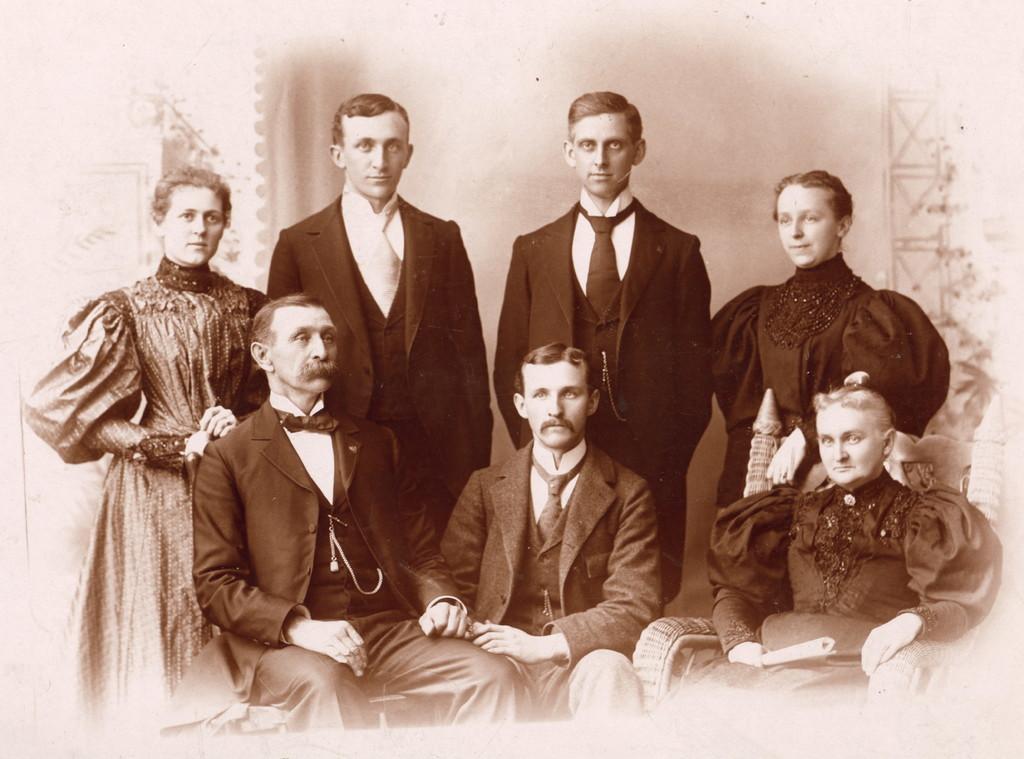How would you summarize this image in a sentence or two? In this image is a photograph. In this image we can see group of persons sitting and standing. In the background there is a curtain and wall. 